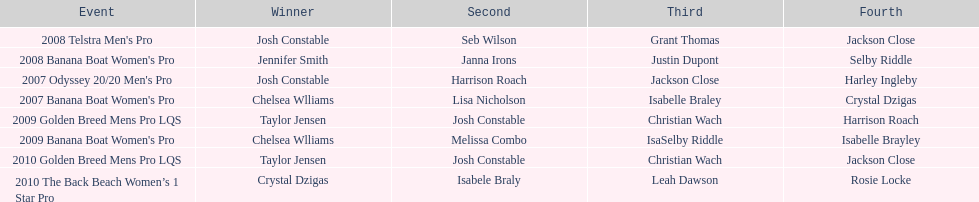Between 2007 and 2010, how many times did chelsea williams emerge as the champion? 2. 